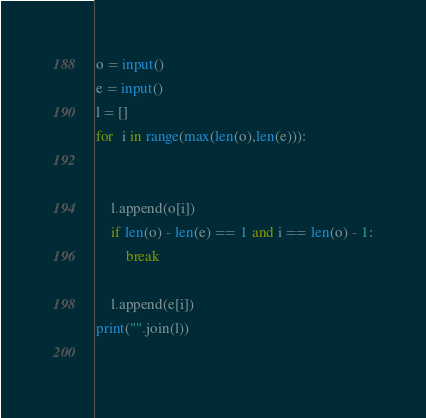Convert code to text. <code><loc_0><loc_0><loc_500><loc_500><_Python_>o = input()
e = input()
l = []
for  i in range(max(len(o),len(e))):
        
        
    l.append(o[i])
    if len(o) - len(e) == 1 and i == len(o) - 1:
        break
        
    l.append(e[i])
print("".join(l))
    </code> 